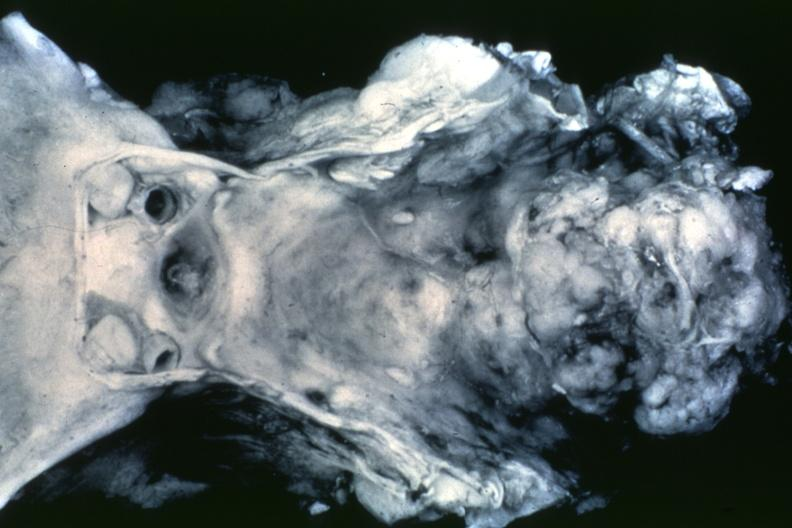what is present?
Answer the question using a single word or phrase. Chordoma 